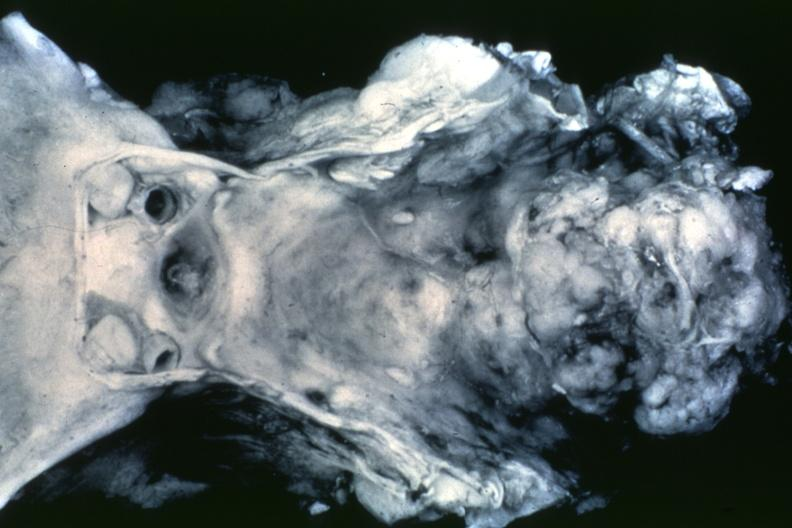what is present?
Answer the question using a single word or phrase. Chordoma 